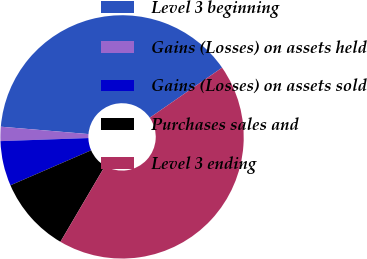Convert chart to OTSL. <chart><loc_0><loc_0><loc_500><loc_500><pie_chart><fcel>Level 3 beginning<fcel>Gains (Losses) on assets held<fcel>Gains (Losses) on assets sold<fcel>Purchases sales and<fcel>Level 3 ending<nl><fcel>39.02%<fcel>1.89%<fcel>5.96%<fcel>10.03%<fcel>43.09%<nl></chart> 